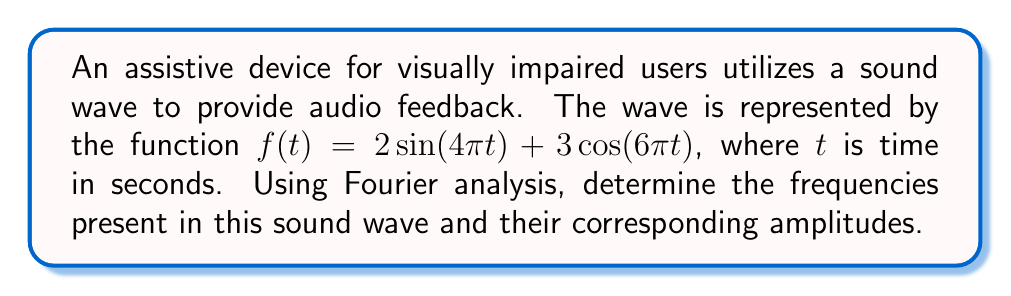Can you answer this question? To analyze this sound wave using Fourier analysis, we need to identify the sinusoidal components of the function. The given function is already in the form of a sum of sine and cosine terms, which makes our analysis straightforward.

Step 1: Identify the general form of a Fourier series
A Fourier series can be represented as:
$$f(t) = \sum_{n=1}^{\infty} [a_n \sin(2\pi n f_0 t) + b_n \cos(2\pi n f_0 t)]$$
where $f_0$ is the fundamental frequency, and $a_n$ and $b_n$ are the amplitudes of the sine and cosine terms, respectively.

Step 2: Compare our function to the general form
Our function: $f(t) = 2\sin(4\pi t) + 3\cos(6\pi t)$

Step 3: Identify the frequencies
For the sine term: $4\pi t = 2\pi (2t)$, so the frequency is 2 Hz
For the cosine term: $6\pi t = 2\pi (3t)$, so the frequency is 3 Hz

Step 4: Identify the amplitudes
The amplitude of the 2 Hz component (sine term) is 2
The amplitude of the 3 Hz component (cosine term) is 3

Therefore, the sound wave consists of two frequency components:
1. A 2 Hz component with an amplitude of 2
2. A 3 Hz component with an amplitude of 3
Answer: 2 Hz (amplitude 2), 3 Hz (amplitude 3) 